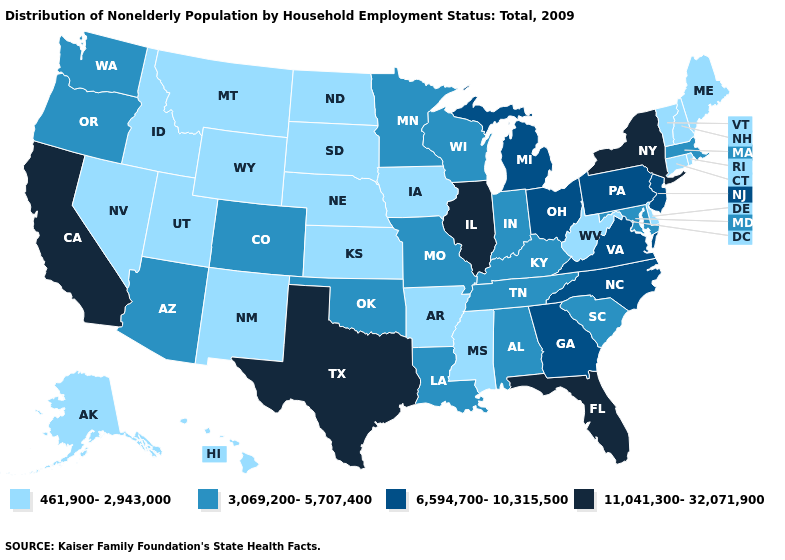Does West Virginia have the lowest value in the USA?
Answer briefly. Yes. Does Michigan have the highest value in the USA?
Concise answer only. No. Among the states that border Alabama , does Florida have the highest value?
Answer briefly. Yes. How many symbols are there in the legend?
Concise answer only. 4. Among the states that border Indiana , which have the lowest value?
Give a very brief answer. Kentucky. What is the value of Rhode Island?
Be succinct. 461,900-2,943,000. Which states have the lowest value in the South?
Concise answer only. Arkansas, Delaware, Mississippi, West Virginia. What is the value of Colorado?
Write a very short answer. 3,069,200-5,707,400. Name the states that have a value in the range 11,041,300-32,071,900?
Concise answer only. California, Florida, Illinois, New York, Texas. What is the value of Maine?
Be succinct. 461,900-2,943,000. What is the value of Idaho?
Be succinct. 461,900-2,943,000. What is the value of Delaware?
Quick response, please. 461,900-2,943,000. What is the value of Georgia?
Short answer required. 6,594,700-10,315,500. Which states have the lowest value in the USA?
Be succinct. Alaska, Arkansas, Connecticut, Delaware, Hawaii, Idaho, Iowa, Kansas, Maine, Mississippi, Montana, Nebraska, Nevada, New Hampshire, New Mexico, North Dakota, Rhode Island, South Dakota, Utah, Vermont, West Virginia, Wyoming. What is the highest value in states that border Alabama?
Be succinct. 11,041,300-32,071,900. 